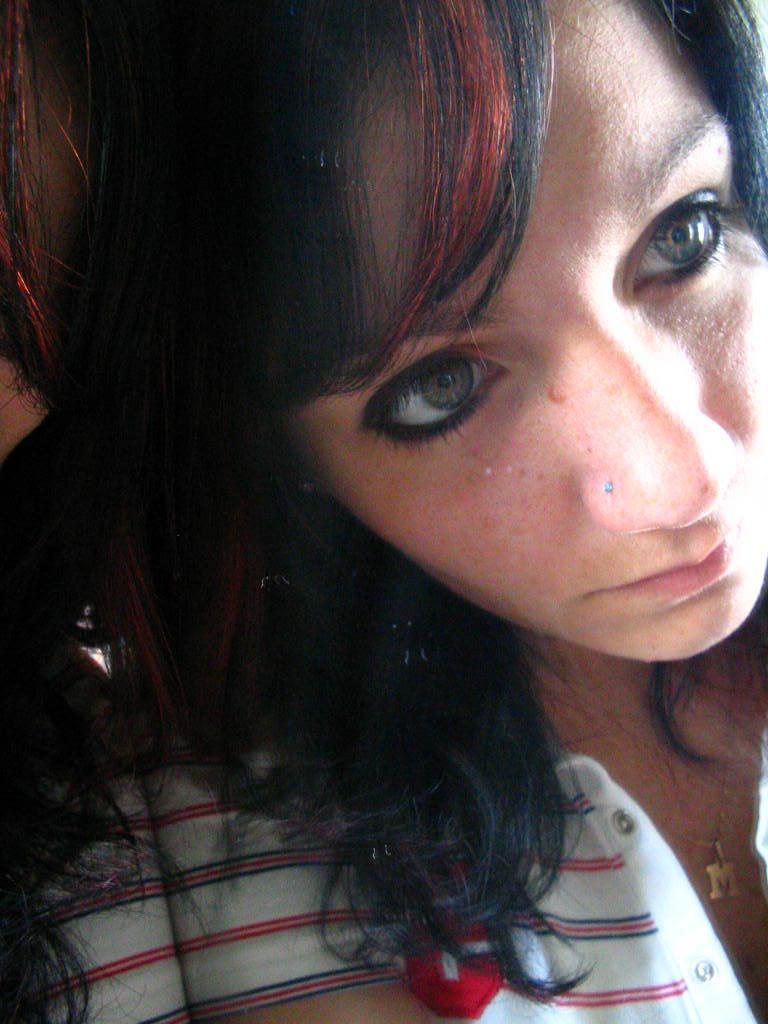Can you describe this image briefly? In this picture I see a woman in front and I see that she is wearing a locket around her neck. 